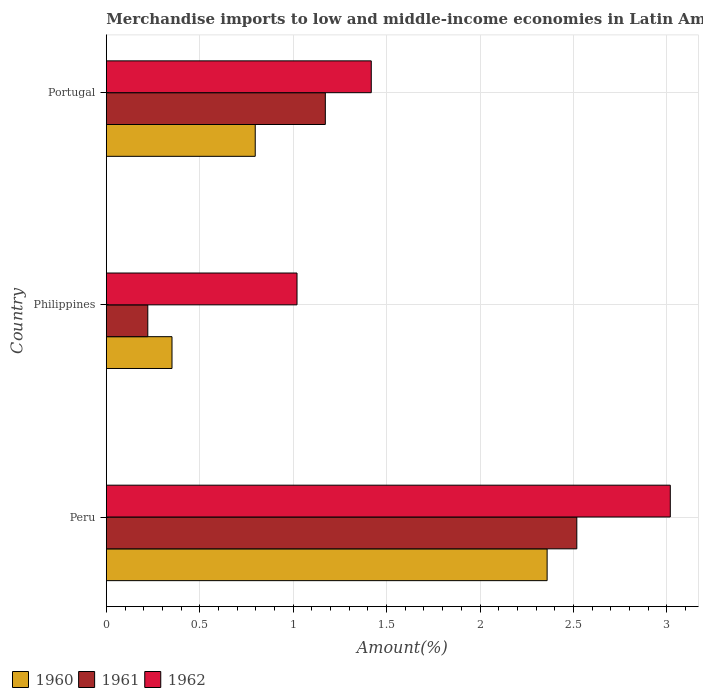How many different coloured bars are there?
Ensure brevity in your answer.  3. Are the number of bars per tick equal to the number of legend labels?
Provide a succinct answer. Yes. How many bars are there on the 2nd tick from the top?
Offer a terse response. 3. How many bars are there on the 2nd tick from the bottom?
Provide a short and direct response. 3. What is the percentage of amount earned from merchandise imports in 1961 in Peru?
Your response must be concise. 2.52. Across all countries, what is the maximum percentage of amount earned from merchandise imports in 1962?
Offer a very short reply. 3.02. Across all countries, what is the minimum percentage of amount earned from merchandise imports in 1960?
Your answer should be compact. 0.35. What is the total percentage of amount earned from merchandise imports in 1961 in the graph?
Your response must be concise. 3.91. What is the difference between the percentage of amount earned from merchandise imports in 1960 in Peru and that in Philippines?
Your answer should be very brief. 2.01. What is the difference between the percentage of amount earned from merchandise imports in 1960 in Peru and the percentage of amount earned from merchandise imports in 1962 in Philippines?
Provide a short and direct response. 1.34. What is the average percentage of amount earned from merchandise imports in 1960 per country?
Ensure brevity in your answer.  1.17. What is the difference between the percentage of amount earned from merchandise imports in 1962 and percentage of amount earned from merchandise imports in 1961 in Philippines?
Provide a short and direct response. 0.8. In how many countries, is the percentage of amount earned from merchandise imports in 1962 greater than 0.5 %?
Provide a succinct answer. 3. What is the ratio of the percentage of amount earned from merchandise imports in 1960 in Peru to that in Philippines?
Provide a succinct answer. 6.71. What is the difference between the highest and the second highest percentage of amount earned from merchandise imports in 1960?
Your answer should be compact. 1.56. What is the difference between the highest and the lowest percentage of amount earned from merchandise imports in 1960?
Your answer should be compact. 2.01. What does the 1st bar from the bottom in Peru represents?
Your answer should be very brief. 1960. How many bars are there?
Make the answer very short. 9. How many countries are there in the graph?
Ensure brevity in your answer.  3. Does the graph contain any zero values?
Provide a short and direct response. No. Does the graph contain grids?
Provide a succinct answer. Yes. Where does the legend appear in the graph?
Your response must be concise. Bottom left. How are the legend labels stacked?
Keep it short and to the point. Horizontal. What is the title of the graph?
Provide a short and direct response. Merchandise imports to low and middle-income economies in Latin America. Does "1978" appear as one of the legend labels in the graph?
Keep it short and to the point. No. What is the label or title of the X-axis?
Your answer should be very brief. Amount(%). What is the label or title of the Y-axis?
Provide a short and direct response. Country. What is the Amount(%) in 1960 in Peru?
Offer a terse response. 2.36. What is the Amount(%) of 1961 in Peru?
Keep it short and to the point. 2.52. What is the Amount(%) of 1962 in Peru?
Your answer should be compact. 3.02. What is the Amount(%) of 1960 in Philippines?
Give a very brief answer. 0.35. What is the Amount(%) in 1961 in Philippines?
Give a very brief answer. 0.22. What is the Amount(%) of 1962 in Philippines?
Your response must be concise. 1.02. What is the Amount(%) in 1960 in Portugal?
Keep it short and to the point. 0.8. What is the Amount(%) of 1961 in Portugal?
Your response must be concise. 1.17. What is the Amount(%) in 1962 in Portugal?
Your answer should be compact. 1.42. Across all countries, what is the maximum Amount(%) of 1960?
Your answer should be compact. 2.36. Across all countries, what is the maximum Amount(%) in 1961?
Provide a succinct answer. 2.52. Across all countries, what is the maximum Amount(%) of 1962?
Your answer should be compact. 3.02. Across all countries, what is the minimum Amount(%) of 1960?
Your answer should be very brief. 0.35. Across all countries, what is the minimum Amount(%) of 1961?
Give a very brief answer. 0.22. Across all countries, what is the minimum Amount(%) of 1962?
Keep it short and to the point. 1.02. What is the total Amount(%) in 1960 in the graph?
Provide a succinct answer. 3.51. What is the total Amount(%) of 1961 in the graph?
Provide a short and direct response. 3.91. What is the total Amount(%) in 1962 in the graph?
Offer a terse response. 5.46. What is the difference between the Amount(%) in 1960 in Peru and that in Philippines?
Your answer should be very brief. 2.01. What is the difference between the Amount(%) in 1961 in Peru and that in Philippines?
Give a very brief answer. 2.3. What is the difference between the Amount(%) in 1962 in Peru and that in Philippines?
Make the answer very short. 2. What is the difference between the Amount(%) in 1960 in Peru and that in Portugal?
Make the answer very short. 1.56. What is the difference between the Amount(%) of 1961 in Peru and that in Portugal?
Keep it short and to the point. 1.35. What is the difference between the Amount(%) in 1962 in Peru and that in Portugal?
Offer a very short reply. 1.6. What is the difference between the Amount(%) in 1960 in Philippines and that in Portugal?
Give a very brief answer. -0.45. What is the difference between the Amount(%) in 1961 in Philippines and that in Portugal?
Provide a succinct answer. -0.95. What is the difference between the Amount(%) in 1962 in Philippines and that in Portugal?
Your answer should be very brief. -0.4. What is the difference between the Amount(%) of 1960 in Peru and the Amount(%) of 1961 in Philippines?
Offer a terse response. 2.14. What is the difference between the Amount(%) in 1960 in Peru and the Amount(%) in 1962 in Philippines?
Your response must be concise. 1.34. What is the difference between the Amount(%) of 1961 in Peru and the Amount(%) of 1962 in Philippines?
Your answer should be compact. 1.5. What is the difference between the Amount(%) in 1960 in Peru and the Amount(%) in 1961 in Portugal?
Offer a terse response. 1.19. What is the difference between the Amount(%) of 1960 in Peru and the Amount(%) of 1962 in Portugal?
Give a very brief answer. 0.94. What is the difference between the Amount(%) in 1961 in Peru and the Amount(%) in 1962 in Portugal?
Offer a terse response. 1.1. What is the difference between the Amount(%) in 1960 in Philippines and the Amount(%) in 1961 in Portugal?
Ensure brevity in your answer.  -0.82. What is the difference between the Amount(%) of 1960 in Philippines and the Amount(%) of 1962 in Portugal?
Your response must be concise. -1.07. What is the difference between the Amount(%) in 1961 in Philippines and the Amount(%) in 1962 in Portugal?
Offer a very short reply. -1.2. What is the average Amount(%) in 1960 per country?
Give a very brief answer. 1.17. What is the average Amount(%) in 1961 per country?
Make the answer very short. 1.3. What is the average Amount(%) in 1962 per country?
Offer a very short reply. 1.82. What is the difference between the Amount(%) of 1960 and Amount(%) of 1961 in Peru?
Make the answer very short. -0.16. What is the difference between the Amount(%) in 1960 and Amount(%) in 1962 in Peru?
Ensure brevity in your answer.  -0.66. What is the difference between the Amount(%) in 1961 and Amount(%) in 1962 in Peru?
Your answer should be very brief. -0.5. What is the difference between the Amount(%) in 1960 and Amount(%) in 1961 in Philippines?
Your response must be concise. 0.13. What is the difference between the Amount(%) of 1960 and Amount(%) of 1962 in Philippines?
Ensure brevity in your answer.  -0.67. What is the difference between the Amount(%) in 1961 and Amount(%) in 1962 in Philippines?
Your response must be concise. -0.8. What is the difference between the Amount(%) of 1960 and Amount(%) of 1961 in Portugal?
Provide a succinct answer. -0.38. What is the difference between the Amount(%) in 1960 and Amount(%) in 1962 in Portugal?
Offer a very short reply. -0.62. What is the difference between the Amount(%) in 1961 and Amount(%) in 1962 in Portugal?
Provide a short and direct response. -0.25. What is the ratio of the Amount(%) of 1960 in Peru to that in Philippines?
Provide a succinct answer. 6.71. What is the ratio of the Amount(%) in 1961 in Peru to that in Philippines?
Keep it short and to the point. 11.35. What is the ratio of the Amount(%) in 1962 in Peru to that in Philippines?
Offer a very short reply. 2.96. What is the ratio of the Amount(%) in 1960 in Peru to that in Portugal?
Your answer should be compact. 2.96. What is the ratio of the Amount(%) in 1961 in Peru to that in Portugal?
Provide a succinct answer. 2.15. What is the ratio of the Amount(%) in 1962 in Peru to that in Portugal?
Give a very brief answer. 2.13. What is the ratio of the Amount(%) of 1960 in Philippines to that in Portugal?
Your response must be concise. 0.44. What is the ratio of the Amount(%) of 1961 in Philippines to that in Portugal?
Offer a terse response. 0.19. What is the ratio of the Amount(%) of 1962 in Philippines to that in Portugal?
Make the answer very short. 0.72. What is the difference between the highest and the second highest Amount(%) in 1960?
Your answer should be compact. 1.56. What is the difference between the highest and the second highest Amount(%) in 1961?
Keep it short and to the point. 1.35. What is the difference between the highest and the second highest Amount(%) in 1962?
Keep it short and to the point. 1.6. What is the difference between the highest and the lowest Amount(%) of 1960?
Offer a very short reply. 2.01. What is the difference between the highest and the lowest Amount(%) of 1961?
Offer a very short reply. 2.3. What is the difference between the highest and the lowest Amount(%) in 1962?
Make the answer very short. 2. 